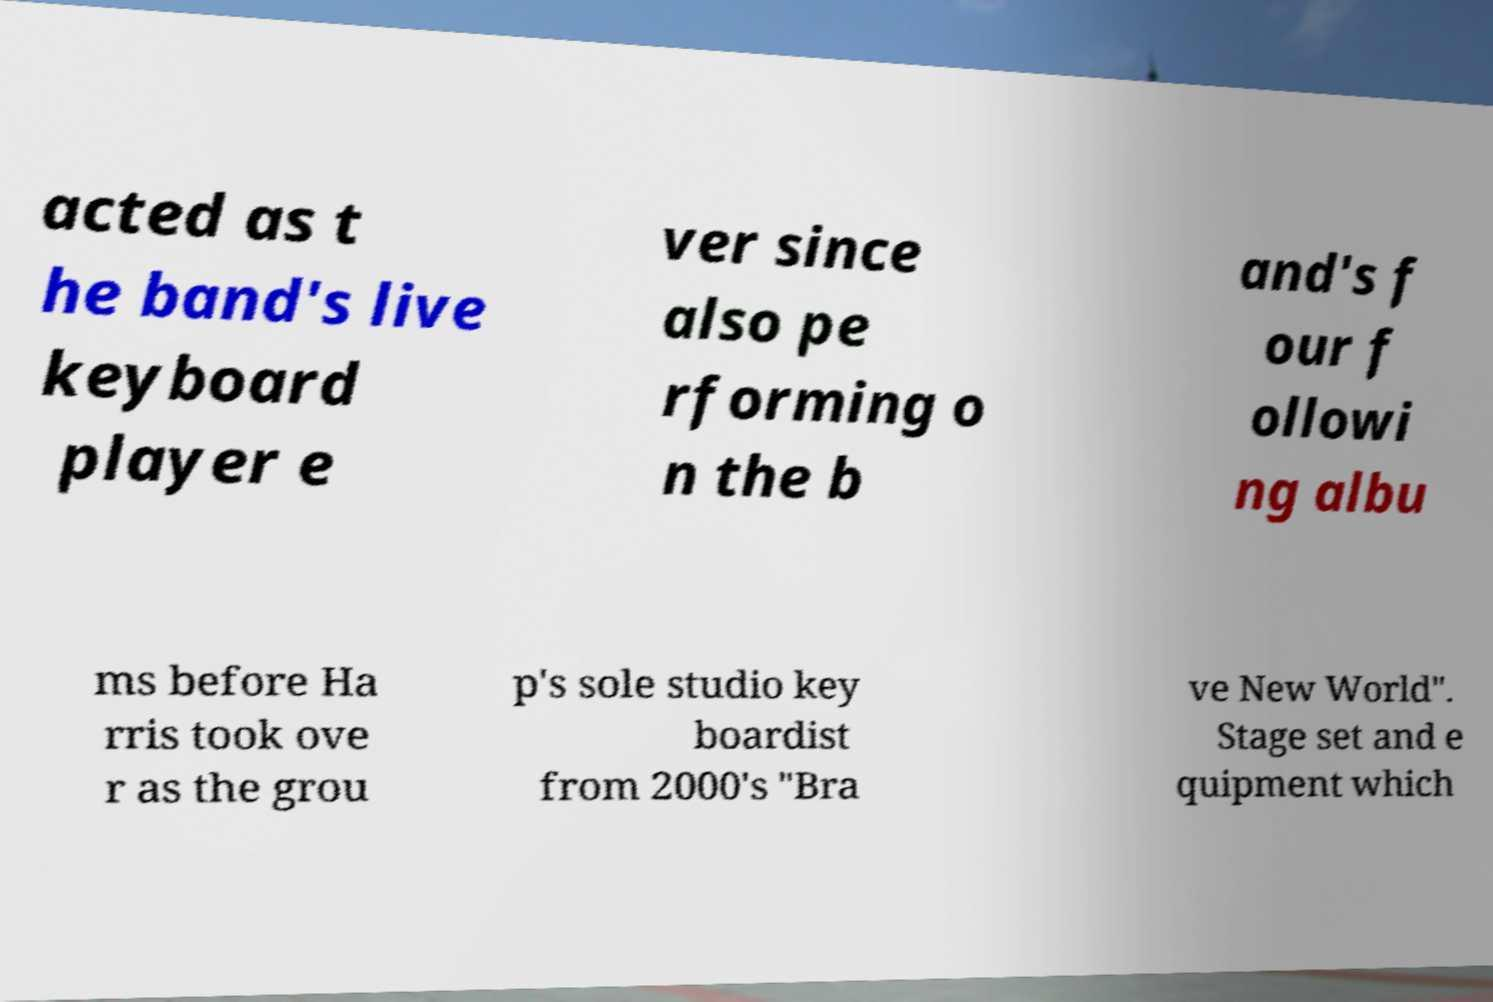Could you assist in decoding the text presented in this image and type it out clearly? acted as t he band's live keyboard player e ver since also pe rforming o n the b and's f our f ollowi ng albu ms before Ha rris took ove r as the grou p's sole studio key boardist from 2000's "Bra ve New World". Stage set and e quipment which 